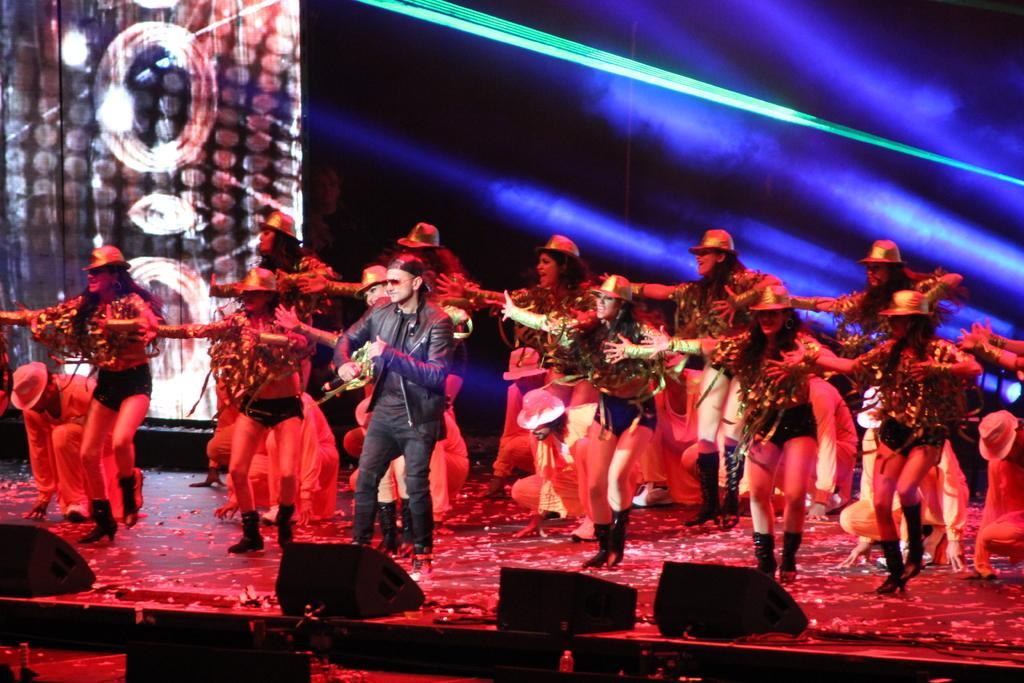Describe this image in one or two sentences. In this picture we can see a group of people on stage and they wore caps and in front of them we can see bottles and some objects and in the background we can see an object, person, lights. 